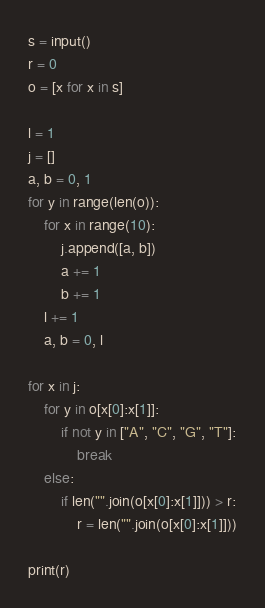Convert code to text. <code><loc_0><loc_0><loc_500><loc_500><_Python_>s = input()
r = 0
o = [x for x in s]

l = 1
j = []
a, b = 0, 1
for y in range(len(o)):
    for x in range(10):
        j.append([a, b])
        a += 1
        b += 1
    l += 1
    a, b = 0, l

for x in j:
    for y in o[x[0]:x[1]]:
        if not y in ["A", "C", "G", "T"]:
            break
    else:
        if len("".join(o[x[0]:x[1]])) > r:
            r = len("".join(o[x[0]:x[1]]))

print(r)
</code> 